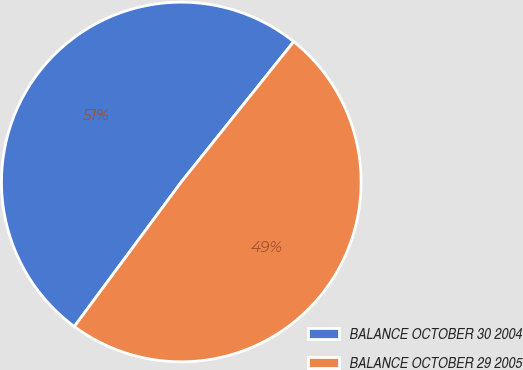Convert chart to OTSL. <chart><loc_0><loc_0><loc_500><loc_500><pie_chart><fcel>BALANCE OCTOBER 30 2004<fcel>BALANCE OCTOBER 29 2005<nl><fcel>50.61%<fcel>49.39%<nl></chart> 